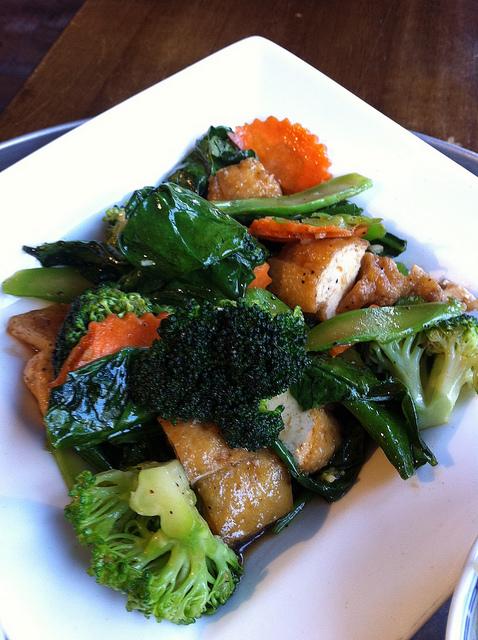Is broccoli one of the ingredients?
Concise answer only. Yes. What is the meat?
Quick response, please. Chicken. Is the plate round?
Give a very brief answer. No. 